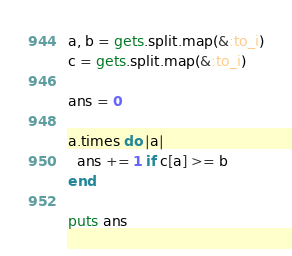<code> <loc_0><loc_0><loc_500><loc_500><_Ruby_>a, b = gets.split.map(&:to_i)
c = gets.split.map(&:to_i)

ans = 0

a.times do |a|
  ans += 1 if c[a] >= b
end

puts ans</code> 